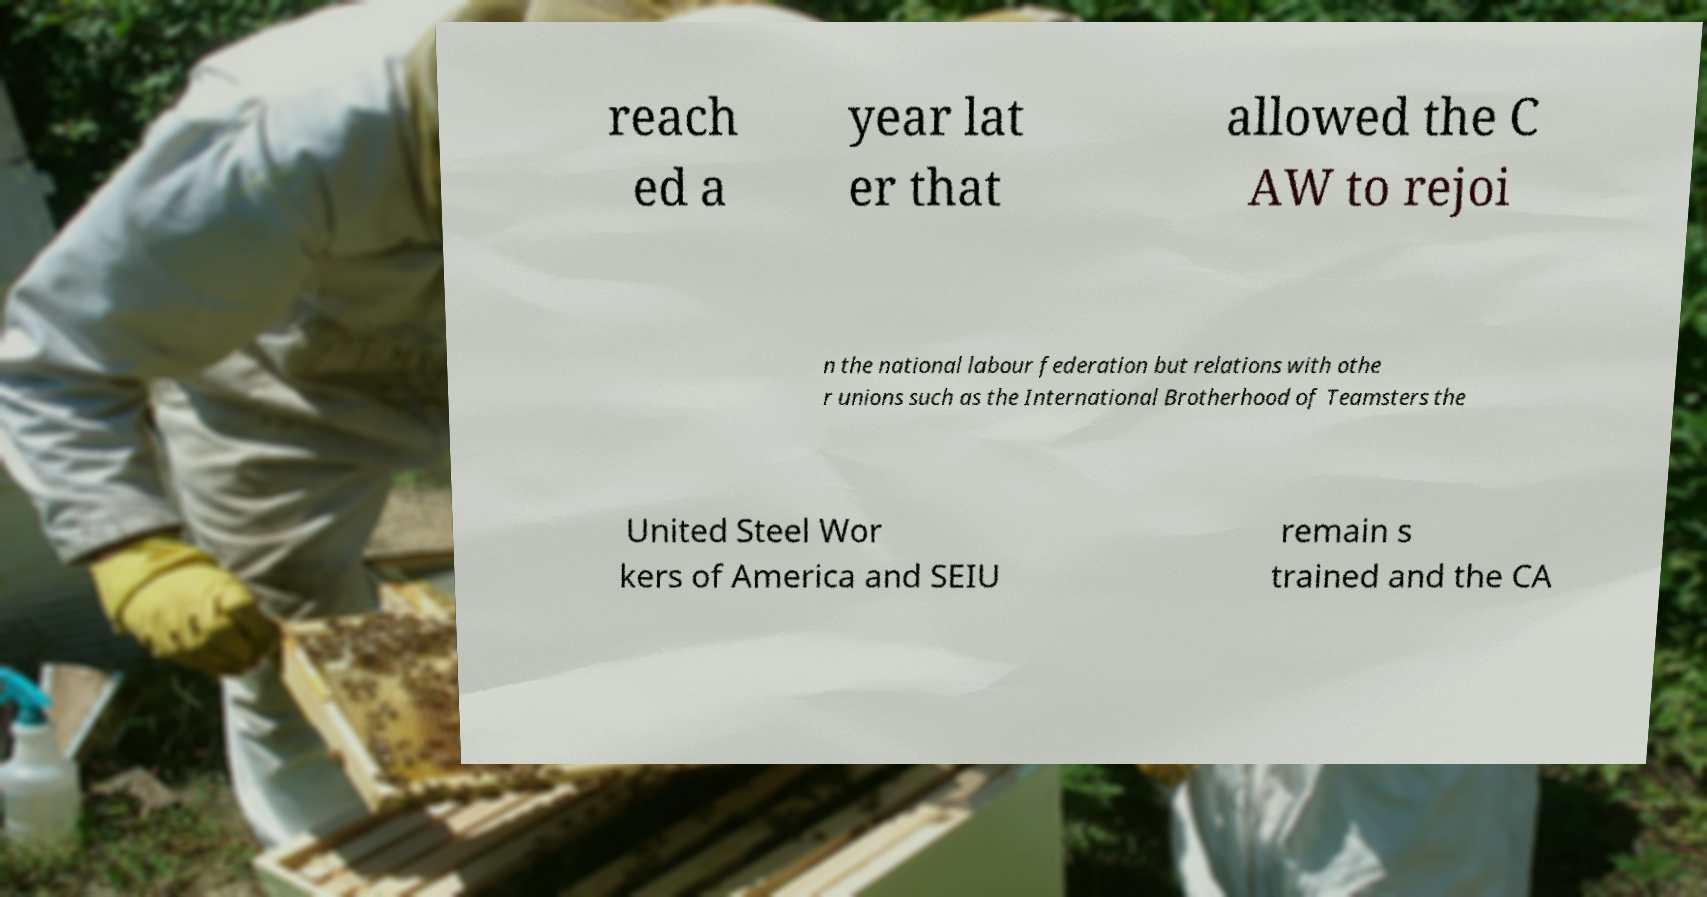Could you extract and type out the text from this image? reach ed a year lat er that allowed the C AW to rejoi n the national labour federation but relations with othe r unions such as the International Brotherhood of Teamsters the United Steel Wor kers of America and SEIU remain s trained and the CA 